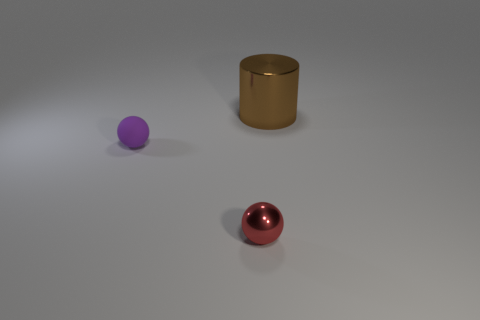What could be the purpose of the arrangement of these objects? The arrangement of these objects could serve various purposes. It could be a simple study in composition and color contrast in a 3D rendering software. Alternatively, it might be part of a visualization for a product design where the objects represent prototypes or items to be displayed. However, without additional context, the exact purpose remains speculative. 